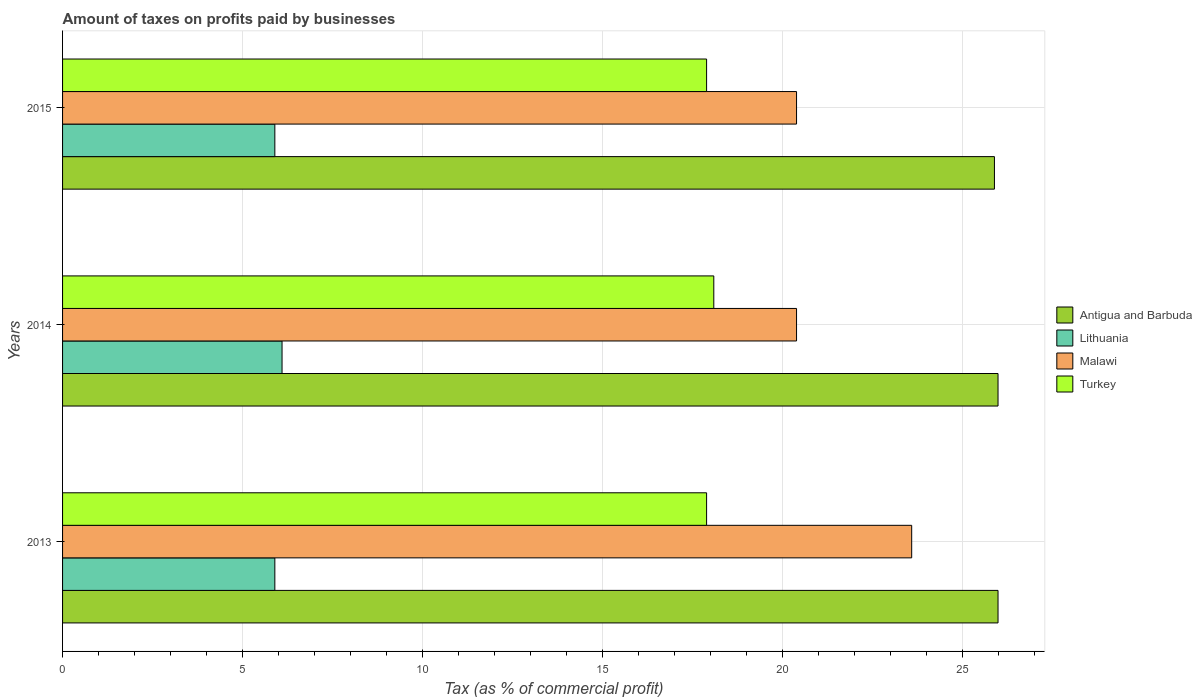How many different coloured bars are there?
Make the answer very short. 4. Are the number of bars on each tick of the Y-axis equal?
Provide a short and direct response. Yes. What is the label of the 1st group of bars from the top?
Give a very brief answer. 2015. In how many cases, is the number of bars for a given year not equal to the number of legend labels?
Provide a succinct answer. 0. Across all years, what is the minimum percentage of taxes paid by businesses in Malawi?
Provide a succinct answer. 20.4. What is the total percentage of taxes paid by businesses in Turkey in the graph?
Offer a very short reply. 53.9. What is the difference between the percentage of taxes paid by businesses in Malawi in 2014 and that in 2015?
Your answer should be compact. 0. What is the difference between the percentage of taxes paid by businesses in Malawi in 2014 and the percentage of taxes paid by businesses in Antigua and Barbuda in 2015?
Keep it short and to the point. -5.5. What is the average percentage of taxes paid by businesses in Malawi per year?
Give a very brief answer. 21.47. In how many years, is the percentage of taxes paid by businesses in Malawi greater than 8 %?
Keep it short and to the point. 3. What is the ratio of the percentage of taxes paid by businesses in Antigua and Barbuda in 2014 to that in 2015?
Provide a short and direct response. 1. Is the percentage of taxes paid by businesses in Malawi in 2013 less than that in 2015?
Your answer should be very brief. No. Is the difference between the percentage of taxes paid by businesses in Turkey in 2013 and 2015 greater than the difference between the percentage of taxes paid by businesses in Antigua and Barbuda in 2013 and 2015?
Keep it short and to the point. No. What is the difference between the highest and the second highest percentage of taxes paid by businesses in Malawi?
Provide a succinct answer. 3.2. What is the difference between the highest and the lowest percentage of taxes paid by businesses in Malawi?
Your response must be concise. 3.2. In how many years, is the percentage of taxes paid by businesses in Turkey greater than the average percentage of taxes paid by businesses in Turkey taken over all years?
Offer a very short reply. 1. Is it the case that in every year, the sum of the percentage of taxes paid by businesses in Antigua and Barbuda and percentage of taxes paid by businesses in Lithuania is greater than the sum of percentage of taxes paid by businesses in Turkey and percentage of taxes paid by businesses in Malawi?
Keep it short and to the point. No. What does the 2nd bar from the top in 2015 represents?
Your answer should be compact. Malawi. What does the 1st bar from the bottom in 2014 represents?
Your response must be concise. Antigua and Barbuda. How many bars are there?
Your answer should be very brief. 12. Are all the bars in the graph horizontal?
Make the answer very short. Yes. How many years are there in the graph?
Offer a very short reply. 3. Does the graph contain grids?
Offer a very short reply. Yes. How many legend labels are there?
Offer a very short reply. 4. How are the legend labels stacked?
Make the answer very short. Vertical. What is the title of the graph?
Ensure brevity in your answer.  Amount of taxes on profits paid by businesses. What is the label or title of the X-axis?
Make the answer very short. Tax (as % of commercial profit). What is the Tax (as % of commercial profit) of Malawi in 2013?
Your answer should be very brief. 23.6. What is the Tax (as % of commercial profit) of Malawi in 2014?
Offer a very short reply. 20.4. What is the Tax (as % of commercial profit) in Antigua and Barbuda in 2015?
Offer a very short reply. 25.9. What is the Tax (as % of commercial profit) in Malawi in 2015?
Keep it short and to the point. 20.4. Across all years, what is the maximum Tax (as % of commercial profit) of Lithuania?
Make the answer very short. 6.1. Across all years, what is the maximum Tax (as % of commercial profit) of Malawi?
Provide a short and direct response. 23.6. Across all years, what is the maximum Tax (as % of commercial profit) in Turkey?
Provide a succinct answer. 18.1. Across all years, what is the minimum Tax (as % of commercial profit) of Antigua and Barbuda?
Offer a terse response. 25.9. Across all years, what is the minimum Tax (as % of commercial profit) in Lithuania?
Give a very brief answer. 5.9. Across all years, what is the minimum Tax (as % of commercial profit) of Malawi?
Make the answer very short. 20.4. Across all years, what is the minimum Tax (as % of commercial profit) of Turkey?
Keep it short and to the point. 17.9. What is the total Tax (as % of commercial profit) of Antigua and Barbuda in the graph?
Provide a short and direct response. 77.9. What is the total Tax (as % of commercial profit) in Malawi in the graph?
Your answer should be very brief. 64.4. What is the total Tax (as % of commercial profit) of Turkey in the graph?
Your answer should be compact. 53.9. What is the difference between the Tax (as % of commercial profit) in Lithuania in 2013 and that in 2014?
Offer a terse response. -0.2. What is the difference between the Tax (as % of commercial profit) of Malawi in 2013 and that in 2014?
Your answer should be compact. 3.2. What is the difference between the Tax (as % of commercial profit) in Turkey in 2013 and that in 2014?
Your answer should be compact. -0.2. What is the difference between the Tax (as % of commercial profit) in Antigua and Barbuda in 2014 and that in 2015?
Offer a very short reply. 0.1. What is the difference between the Tax (as % of commercial profit) in Lithuania in 2014 and that in 2015?
Make the answer very short. 0.2. What is the difference between the Tax (as % of commercial profit) of Malawi in 2014 and that in 2015?
Give a very brief answer. 0. What is the difference between the Tax (as % of commercial profit) of Turkey in 2014 and that in 2015?
Provide a short and direct response. 0.2. What is the difference between the Tax (as % of commercial profit) in Lithuania in 2013 and the Tax (as % of commercial profit) in Turkey in 2014?
Give a very brief answer. -12.2. What is the difference between the Tax (as % of commercial profit) in Antigua and Barbuda in 2013 and the Tax (as % of commercial profit) in Lithuania in 2015?
Offer a terse response. 20.1. What is the difference between the Tax (as % of commercial profit) of Antigua and Barbuda in 2013 and the Tax (as % of commercial profit) of Malawi in 2015?
Provide a short and direct response. 5.6. What is the difference between the Tax (as % of commercial profit) of Lithuania in 2013 and the Tax (as % of commercial profit) of Malawi in 2015?
Keep it short and to the point. -14.5. What is the difference between the Tax (as % of commercial profit) in Malawi in 2013 and the Tax (as % of commercial profit) in Turkey in 2015?
Your response must be concise. 5.7. What is the difference between the Tax (as % of commercial profit) of Antigua and Barbuda in 2014 and the Tax (as % of commercial profit) of Lithuania in 2015?
Ensure brevity in your answer.  20.1. What is the difference between the Tax (as % of commercial profit) of Antigua and Barbuda in 2014 and the Tax (as % of commercial profit) of Turkey in 2015?
Offer a very short reply. 8.1. What is the difference between the Tax (as % of commercial profit) in Lithuania in 2014 and the Tax (as % of commercial profit) in Malawi in 2015?
Make the answer very short. -14.3. What is the difference between the Tax (as % of commercial profit) in Malawi in 2014 and the Tax (as % of commercial profit) in Turkey in 2015?
Your answer should be very brief. 2.5. What is the average Tax (as % of commercial profit) of Antigua and Barbuda per year?
Provide a succinct answer. 25.97. What is the average Tax (as % of commercial profit) of Lithuania per year?
Provide a short and direct response. 5.97. What is the average Tax (as % of commercial profit) in Malawi per year?
Give a very brief answer. 21.47. What is the average Tax (as % of commercial profit) of Turkey per year?
Give a very brief answer. 17.97. In the year 2013, what is the difference between the Tax (as % of commercial profit) of Antigua and Barbuda and Tax (as % of commercial profit) of Lithuania?
Offer a very short reply. 20.1. In the year 2013, what is the difference between the Tax (as % of commercial profit) of Antigua and Barbuda and Tax (as % of commercial profit) of Turkey?
Ensure brevity in your answer.  8.1. In the year 2013, what is the difference between the Tax (as % of commercial profit) in Lithuania and Tax (as % of commercial profit) in Malawi?
Your answer should be very brief. -17.7. In the year 2013, what is the difference between the Tax (as % of commercial profit) in Lithuania and Tax (as % of commercial profit) in Turkey?
Your response must be concise. -12. In the year 2014, what is the difference between the Tax (as % of commercial profit) in Antigua and Barbuda and Tax (as % of commercial profit) in Malawi?
Provide a succinct answer. 5.6. In the year 2014, what is the difference between the Tax (as % of commercial profit) in Antigua and Barbuda and Tax (as % of commercial profit) in Turkey?
Your response must be concise. 7.9. In the year 2014, what is the difference between the Tax (as % of commercial profit) of Lithuania and Tax (as % of commercial profit) of Malawi?
Give a very brief answer. -14.3. In the year 2014, what is the difference between the Tax (as % of commercial profit) of Malawi and Tax (as % of commercial profit) of Turkey?
Your answer should be compact. 2.3. In the year 2015, what is the difference between the Tax (as % of commercial profit) of Antigua and Barbuda and Tax (as % of commercial profit) of Malawi?
Ensure brevity in your answer.  5.5. In the year 2015, what is the difference between the Tax (as % of commercial profit) of Lithuania and Tax (as % of commercial profit) of Turkey?
Give a very brief answer. -12. In the year 2015, what is the difference between the Tax (as % of commercial profit) in Malawi and Tax (as % of commercial profit) in Turkey?
Ensure brevity in your answer.  2.5. What is the ratio of the Tax (as % of commercial profit) of Lithuania in 2013 to that in 2014?
Make the answer very short. 0.97. What is the ratio of the Tax (as % of commercial profit) in Malawi in 2013 to that in 2014?
Make the answer very short. 1.16. What is the ratio of the Tax (as % of commercial profit) of Antigua and Barbuda in 2013 to that in 2015?
Your answer should be very brief. 1. What is the ratio of the Tax (as % of commercial profit) of Malawi in 2013 to that in 2015?
Your answer should be compact. 1.16. What is the ratio of the Tax (as % of commercial profit) of Antigua and Barbuda in 2014 to that in 2015?
Give a very brief answer. 1. What is the ratio of the Tax (as % of commercial profit) of Lithuania in 2014 to that in 2015?
Provide a succinct answer. 1.03. What is the ratio of the Tax (as % of commercial profit) of Turkey in 2014 to that in 2015?
Your answer should be compact. 1.01. What is the difference between the highest and the second highest Tax (as % of commercial profit) in Antigua and Barbuda?
Your answer should be very brief. 0. What is the difference between the highest and the second highest Tax (as % of commercial profit) of Turkey?
Keep it short and to the point. 0.2. What is the difference between the highest and the lowest Tax (as % of commercial profit) of Lithuania?
Keep it short and to the point. 0.2. What is the difference between the highest and the lowest Tax (as % of commercial profit) of Turkey?
Keep it short and to the point. 0.2. 